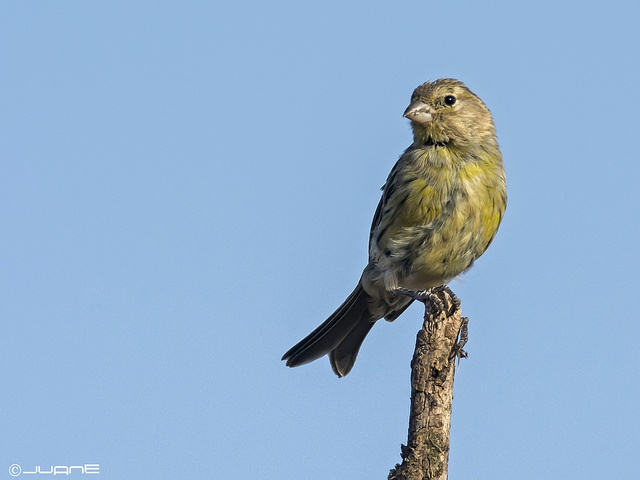Describe the objects in this image and their specific colors. I can see a bird in lightblue, black, tan, gray, and darkgreen tones in this image. 